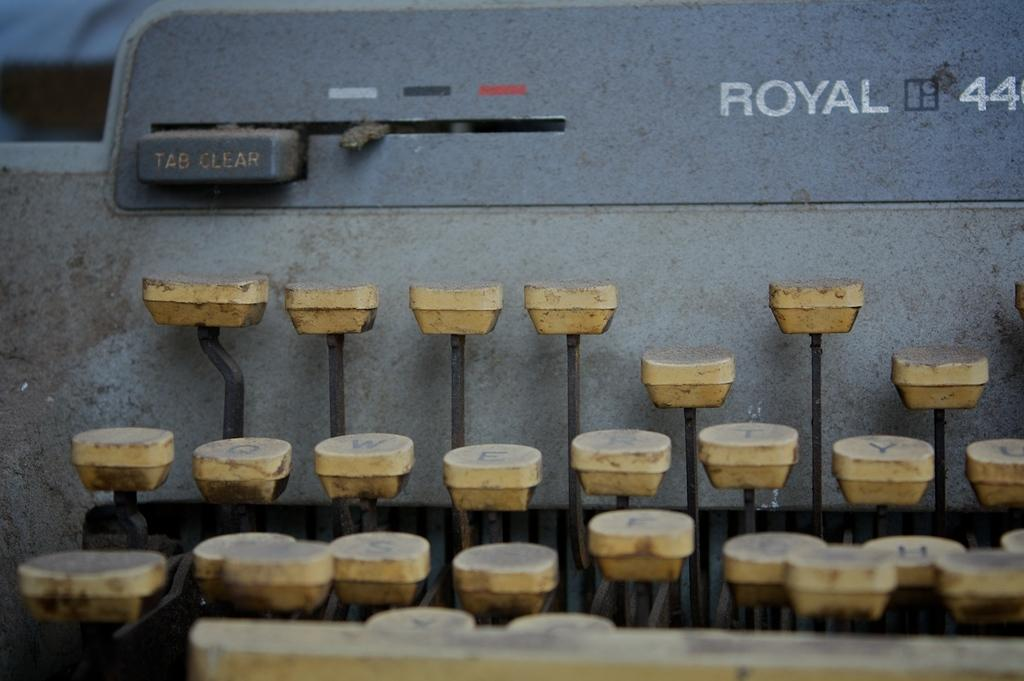What is the main object in the image? The main object in the image is a typewriter machine. What specific feature can be seen on the typewriter machine? There is a tab clear button on the typewriter machine. What can be used to input text on the typewriter machine? The typewriter machine has keys with letters on them. What type of group activity is taking place with the typewriter machine in the image? There is no group activity present in the image; it only features the typewriter machine. How does the typewriter machine contribute to the play experience in the image? The image does not depict a play experience, and the typewriter machine is not used for play. 